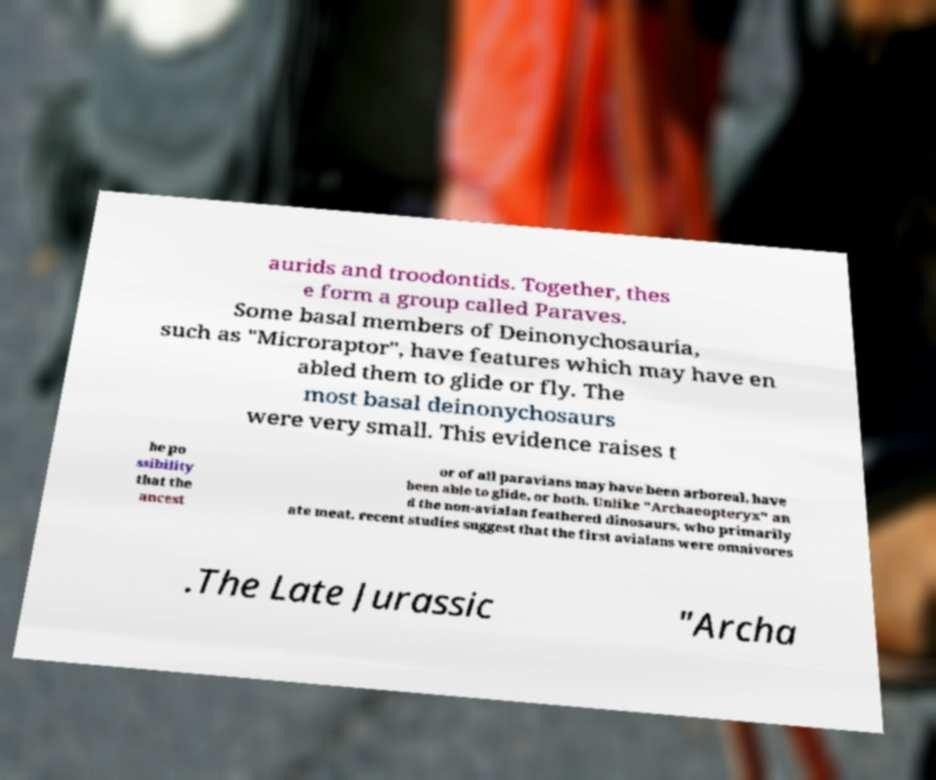Can you accurately transcribe the text from the provided image for me? aurids and troodontids. Together, thes e form a group called Paraves. Some basal members of Deinonychosauria, such as "Microraptor", have features which may have en abled them to glide or fly. The most basal deinonychosaurs were very small. This evidence raises t he po ssibility that the ancest or of all paravians may have been arboreal, have been able to glide, or both. Unlike "Archaeopteryx" an d the non-avialan feathered dinosaurs, who primarily ate meat, recent studies suggest that the first avialans were omnivores .The Late Jurassic "Archa 